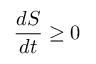Convert formula to latex. <formula><loc_0><loc_0><loc_500><loc_500>{ \frac { d S } { d t } } \geq 0</formula> 